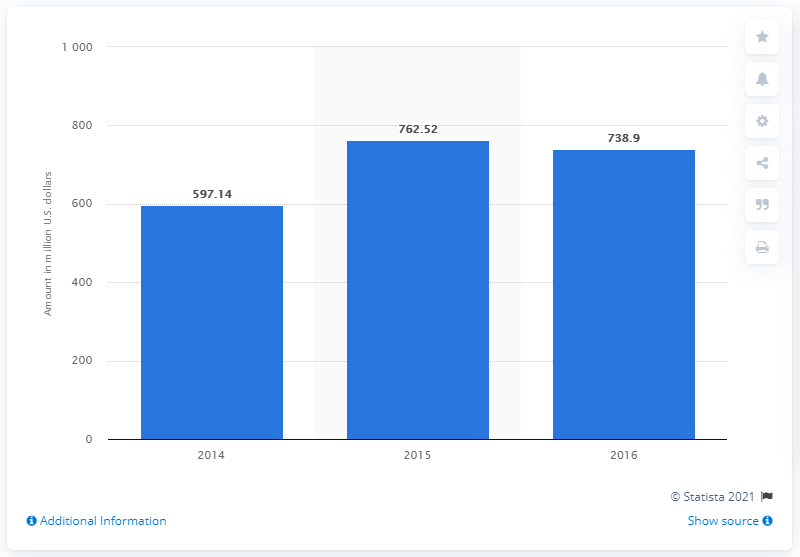Point out several critical features in this image. The crowdfunding process raised $738.9 in 2016. 